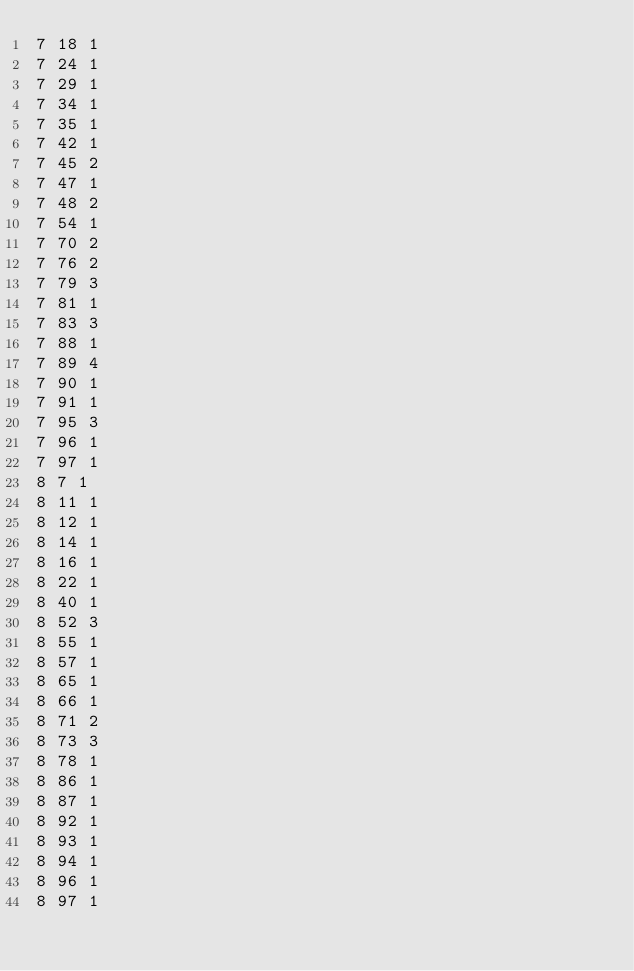<code> <loc_0><loc_0><loc_500><loc_500><_ObjectiveC_>7 18 1
7 24 1
7 29 1
7 34 1
7 35 1
7 42 1
7 45 2
7 47 1
7 48 2
7 54 1
7 70 2
7 76 2
7 79 3
7 81 1
7 83 3
7 88 1
7 89 4
7 90 1
7 91 1
7 95 3
7 96 1
7 97 1
8 7 1
8 11 1
8 12 1
8 14 1
8 16 1
8 22 1
8 40 1
8 52 3
8 55 1
8 57 1
8 65 1
8 66 1
8 71 2
8 73 3
8 78 1
8 86 1
8 87 1
8 92 1
8 93 1
8 94 1
8 96 1
8 97 1
</code> 